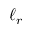Convert formula to latex. <formula><loc_0><loc_0><loc_500><loc_500>\ell _ { r }</formula> 